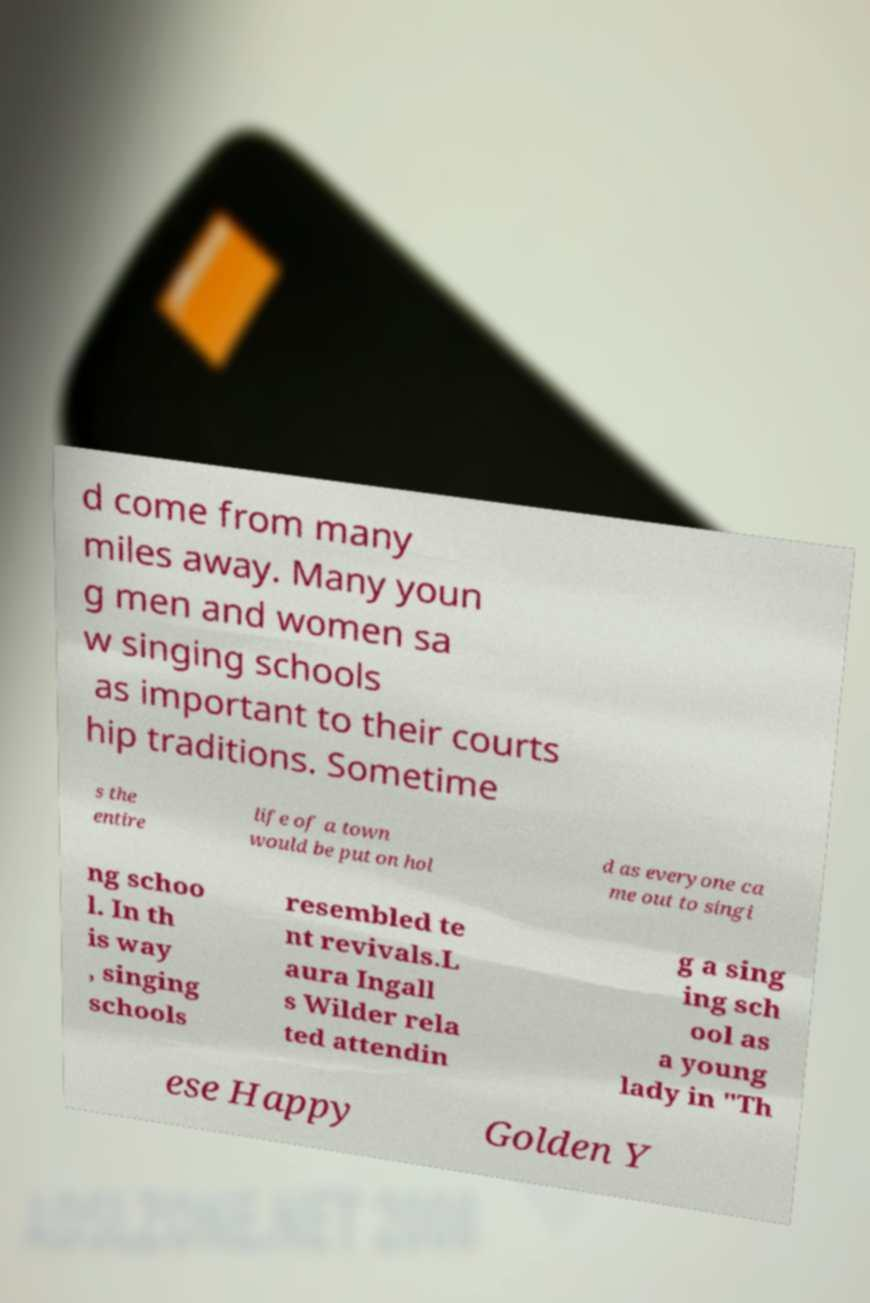What messages or text are displayed in this image? I need them in a readable, typed format. d come from many miles away. Many youn g men and women sa w singing schools as important to their courts hip traditions. Sometime s the entire life of a town would be put on hol d as everyone ca me out to singi ng schoo l. In th is way , singing schools resembled te nt revivals.L aura Ingall s Wilder rela ted attendin g a sing ing sch ool as a young lady in "Th ese Happy Golden Y 